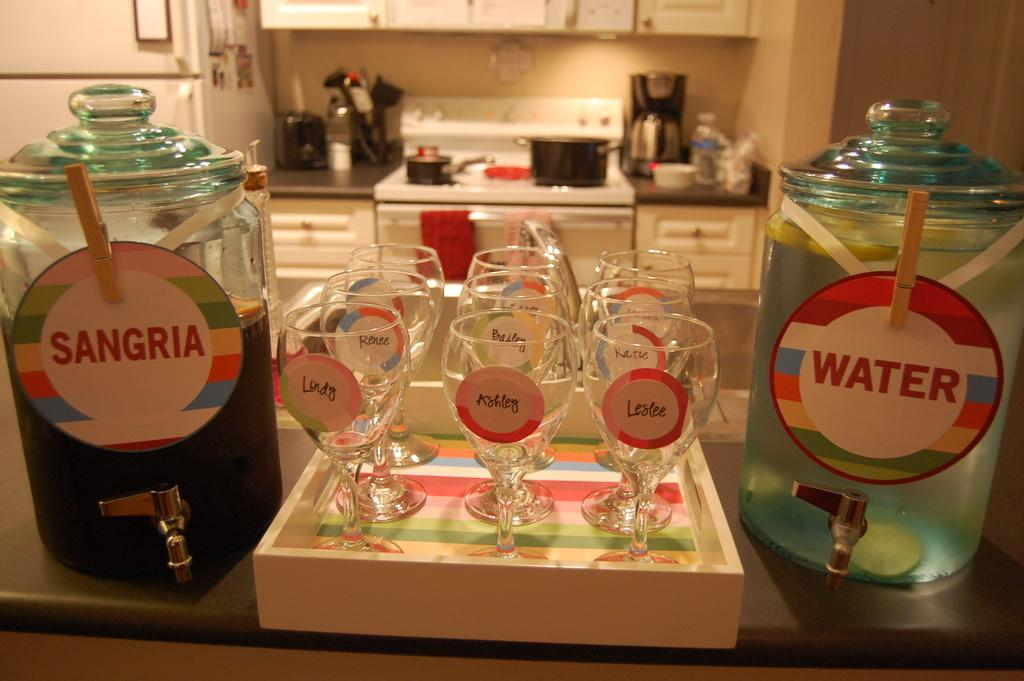<image>
Offer a succinct explanation of the picture presented. A bar set up with labeled glasses and water and sangria. 